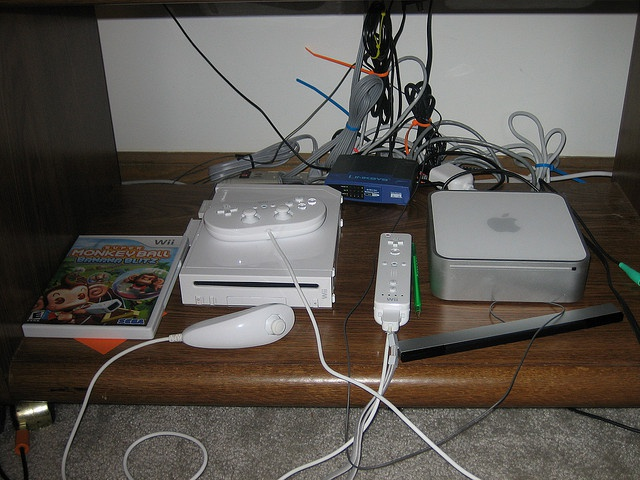Describe the objects in this image and their specific colors. I can see book in black, gray, and maroon tones, remote in black, darkgray, lightgray, and gray tones, remote in black, darkgray, lightgray, and gray tones, remote in black, darkgray, lightgray, and gray tones, and apple in black and gray tones in this image. 